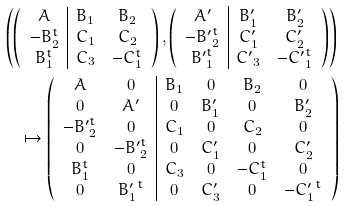Convert formula to latex. <formula><loc_0><loc_0><loc_500><loc_500>& \left ( \left ( \begin{array} { c | c c } A & B _ { 1 } & B _ { 2 } \\ - B _ { 2 } ^ { t } & C _ { 1 } & C _ { 2 } \\ B _ { 1 } ^ { t } & C _ { 3 } & - C _ { 1 } ^ { t } \end{array} \right ) , \left ( \begin{array} { c | c c } A ^ { \prime } & B ^ { \prime } _ { 1 } & B ^ { \prime } _ { 2 } \\ - { B ^ { \prime } } _ { 2 } ^ { t } & C ^ { \prime } _ { 1 } & C ^ { \prime } _ { 2 } \\ { B ^ { \prime } } _ { 1 } ^ { t } & { C ^ { \prime } } _ { 3 } & - { C ^ { \prime } } _ { 1 } ^ { t } \end{array} \right ) \right ) \\ & \quad \mapsto \left ( \begin{array} { c c | c c c c } A & 0 & B _ { 1 } & 0 & B _ { 2 } & 0 \\ 0 & A ^ { \prime } & 0 & B ^ { \prime } _ { 1 } & 0 & B ^ { \prime } _ { 2 } \\ - { B ^ { \prime } } _ { 2 } ^ { t } & 0 & C _ { 1 } & 0 & C _ { 2 } & 0 \\ 0 & - { B ^ { \prime } } _ { 2 } ^ { t } & 0 & C ^ { \prime } _ { 1 } & 0 & C ^ { \prime } _ { 2 } \\ B _ { 1 } ^ { t } & 0 & C _ { 3 } & 0 & - C _ { 1 } ^ { t } & 0 \\ 0 & { B _ { 1 } ^ { \prime } } ^ { t } & 0 & { C _ { 3 } ^ { \prime } } & 0 & - { C _ { 1 } ^ { \prime } } ^ { t } \end{array} \right )</formula> 